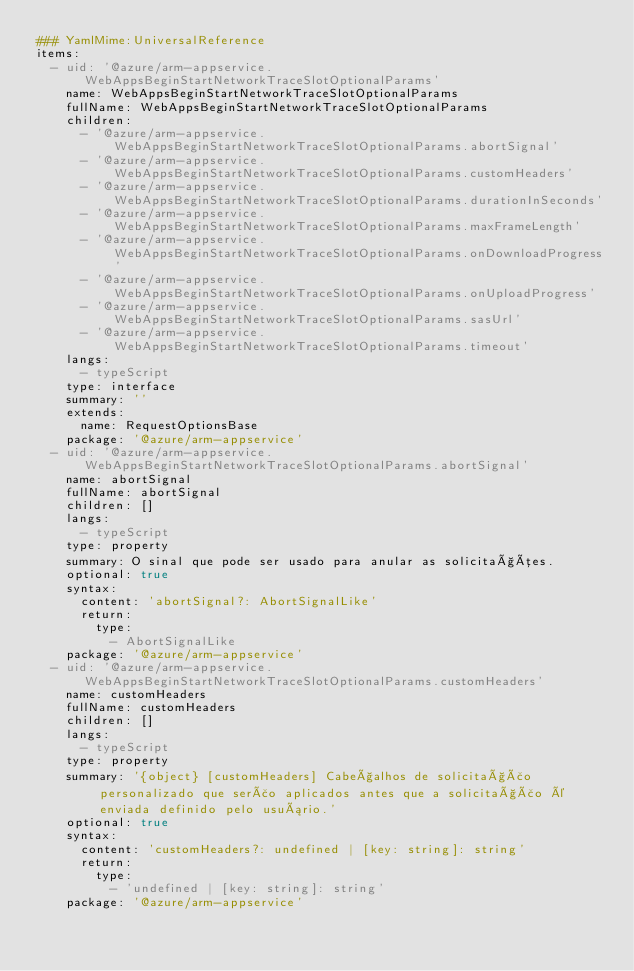<code> <loc_0><loc_0><loc_500><loc_500><_YAML_>### YamlMime:UniversalReference
items:
  - uid: '@azure/arm-appservice.WebAppsBeginStartNetworkTraceSlotOptionalParams'
    name: WebAppsBeginStartNetworkTraceSlotOptionalParams
    fullName: WebAppsBeginStartNetworkTraceSlotOptionalParams
    children:
      - '@azure/arm-appservice.WebAppsBeginStartNetworkTraceSlotOptionalParams.abortSignal'
      - '@azure/arm-appservice.WebAppsBeginStartNetworkTraceSlotOptionalParams.customHeaders'
      - '@azure/arm-appservice.WebAppsBeginStartNetworkTraceSlotOptionalParams.durationInSeconds'
      - '@azure/arm-appservice.WebAppsBeginStartNetworkTraceSlotOptionalParams.maxFrameLength'
      - '@azure/arm-appservice.WebAppsBeginStartNetworkTraceSlotOptionalParams.onDownloadProgress'
      - '@azure/arm-appservice.WebAppsBeginStartNetworkTraceSlotOptionalParams.onUploadProgress'
      - '@azure/arm-appservice.WebAppsBeginStartNetworkTraceSlotOptionalParams.sasUrl'
      - '@azure/arm-appservice.WebAppsBeginStartNetworkTraceSlotOptionalParams.timeout'
    langs:
      - typeScript
    type: interface
    summary: ''
    extends:
      name: RequestOptionsBase
    package: '@azure/arm-appservice'
  - uid: '@azure/arm-appservice.WebAppsBeginStartNetworkTraceSlotOptionalParams.abortSignal'
    name: abortSignal
    fullName: abortSignal
    children: []
    langs:
      - typeScript
    type: property
    summary: O sinal que pode ser usado para anular as solicitações.
    optional: true
    syntax:
      content: 'abortSignal?: AbortSignalLike'
      return:
        type:
          - AbortSignalLike
    package: '@azure/arm-appservice'
  - uid: '@azure/arm-appservice.WebAppsBeginStartNetworkTraceSlotOptionalParams.customHeaders'
    name: customHeaders
    fullName: customHeaders
    children: []
    langs:
      - typeScript
    type: property
    summary: '{object} [customHeaders] Cabeçalhos de solicitação personalizado que serão aplicados antes que a solicitação é enviada definido pelo usuário.'
    optional: true
    syntax:
      content: 'customHeaders?: undefined | [key: string]: string'
      return:
        type:
          - 'undefined | [key: string]: string'
    package: '@azure/arm-appservice'</code> 